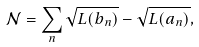<formula> <loc_0><loc_0><loc_500><loc_500>\mathcal { N } = \sum _ { n } \sqrt { L ( b _ { n } ) } - \sqrt { L ( a _ { n } ) } ,</formula> 